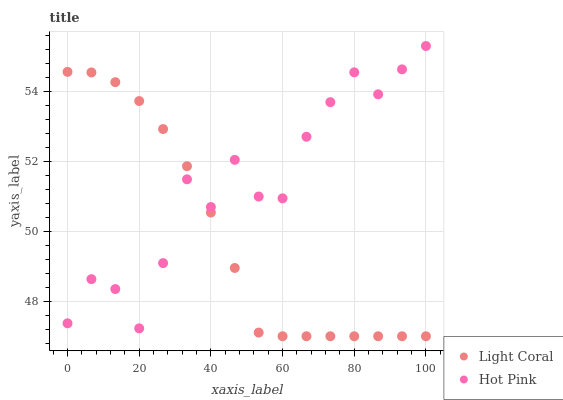Does Light Coral have the minimum area under the curve?
Answer yes or no. Yes. Does Hot Pink have the maximum area under the curve?
Answer yes or no. Yes. Does Hot Pink have the minimum area under the curve?
Answer yes or no. No. Is Light Coral the smoothest?
Answer yes or no. Yes. Is Hot Pink the roughest?
Answer yes or no. Yes. Is Hot Pink the smoothest?
Answer yes or no. No. Does Light Coral have the lowest value?
Answer yes or no. Yes. Does Hot Pink have the lowest value?
Answer yes or no. No. Does Hot Pink have the highest value?
Answer yes or no. Yes. Does Hot Pink intersect Light Coral?
Answer yes or no. Yes. Is Hot Pink less than Light Coral?
Answer yes or no. No. Is Hot Pink greater than Light Coral?
Answer yes or no. No. 